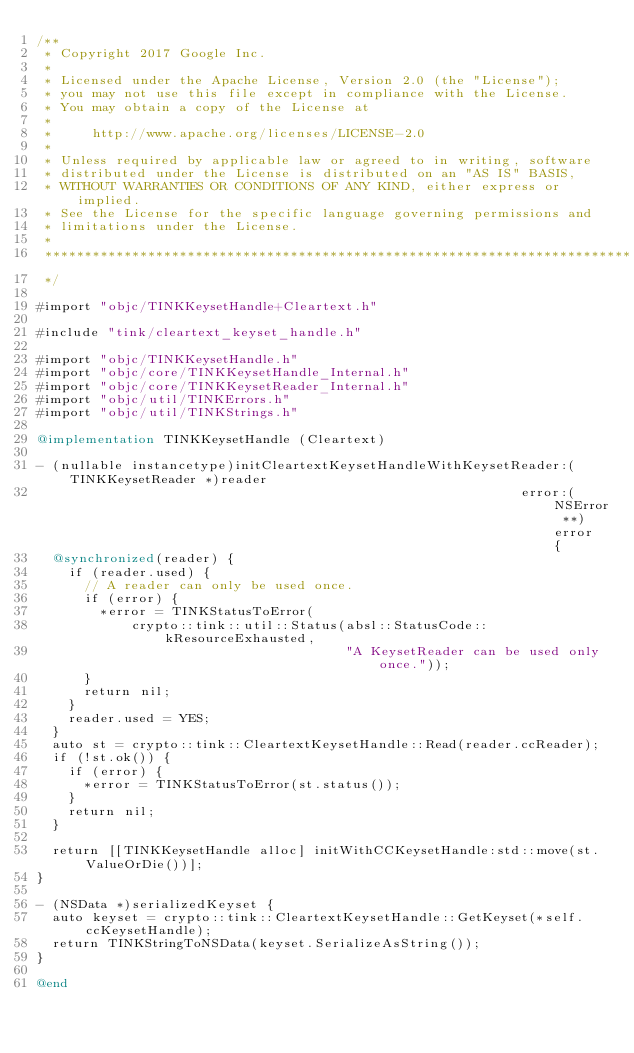<code> <loc_0><loc_0><loc_500><loc_500><_ObjectiveC_>/**
 * Copyright 2017 Google Inc.
 *
 * Licensed under the Apache License, Version 2.0 (the "License");
 * you may not use this file except in compliance with the License.
 * You may obtain a copy of the License at
 *
 *     http://www.apache.org/licenses/LICENSE-2.0
 *
 * Unless required by applicable law or agreed to in writing, software
 * distributed under the License is distributed on an "AS IS" BASIS,
 * WITHOUT WARRANTIES OR CONDITIONS OF ANY KIND, either express or implied.
 * See the License for the specific language governing permissions and
 * limitations under the License.
 *
 **************************************************************************
 */

#import "objc/TINKKeysetHandle+Cleartext.h"

#include "tink/cleartext_keyset_handle.h"

#import "objc/TINKKeysetHandle.h"
#import "objc/core/TINKKeysetHandle_Internal.h"
#import "objc/core/TINKKeysetReader_Internal.h"
#import "objc/util/TINKErrors.h"
#import "objc/util/TINKStrings.h"

@implementation TINKKeysetHandle (Cleartext)

- (nullable instancetype)initCleartextKeysetHandleWithKeysetReader:(TINKKeysetReader *)reader
                                                             error:(NSError **)error {
  @synchronized(reader) {
    if (reader.used) {
      // A reader can only be used once.
      if (error) {
        *error = TINKStatusToError(
            crypto::tink::util::Status(absl::StatusCode::kResourceExhausted,
                                       "A KeysetReader can be used only once."));
      }
      return nil;
    }
    reader.used = YES;
  }
  auto st = crypto::tink::CleartextKeysetHandle::Read(reader.ccReader);
  if (!st.ok()) {
    if (error) {
      *error = TINKStatusToError(st.status());
    }
    return nil;
  }

  return [[TINKKeysetHandle alloc] initWithCCKeysetHandle:std::move(st.ValueOrDie())];
}

- (NSData *)serializedKeyset {
  auto keyset = crypto::tink::CleartextKeysetHandle::GetKeyset(*self.ccKeysetHandle);
  return TINKStringToNSData(keyset.SerializeAsString());
}

@end
</code> 